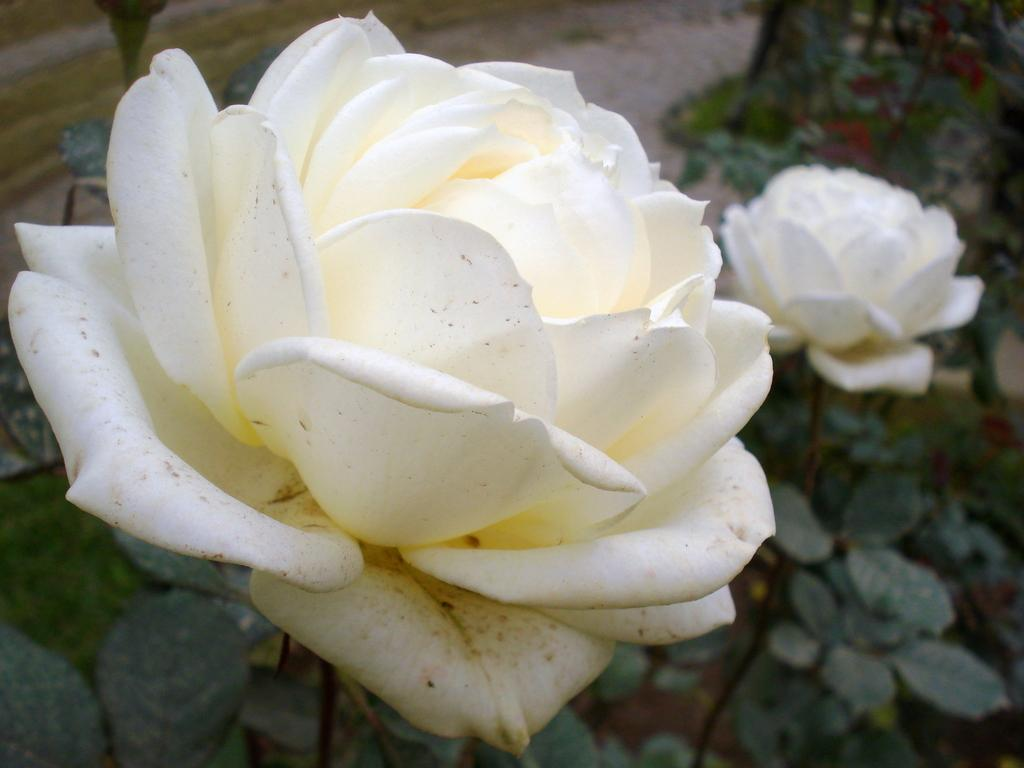What type of flowers can be seen in the image? There are two white color flowers in the image. What color are the leaves in the image? The leaves in the image are green. What type of board is being used for the battle in the image? There is no board or battle present in the image; it features two white color flowers and green leaves. Can you see a bird in the image? There is no bird present in the image. 